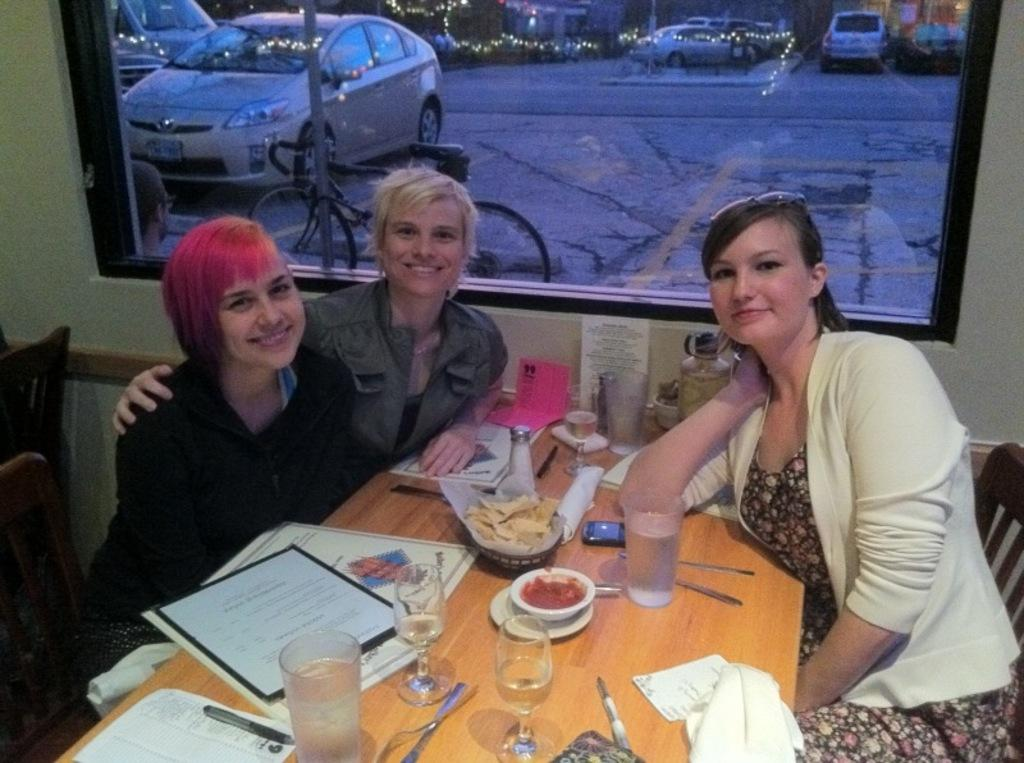How many people are sitting around the table in the image? There are three persons sitting on chairs around a table. What can be found on the table in the image? There are food items on the table. Can you describe something in the background of the image? There is a glass in the background. What else can be seen in the background of the image? There are vehicles and a road in the background. What type of lighting is present in the background of the image? There is light in the background. Is there a jail visible in the image? No, there is no jail present in the image. What type of bean is being used as a support for the table in the image? There is no bean used as a support for the table in the image; the table is supported by its legs. 